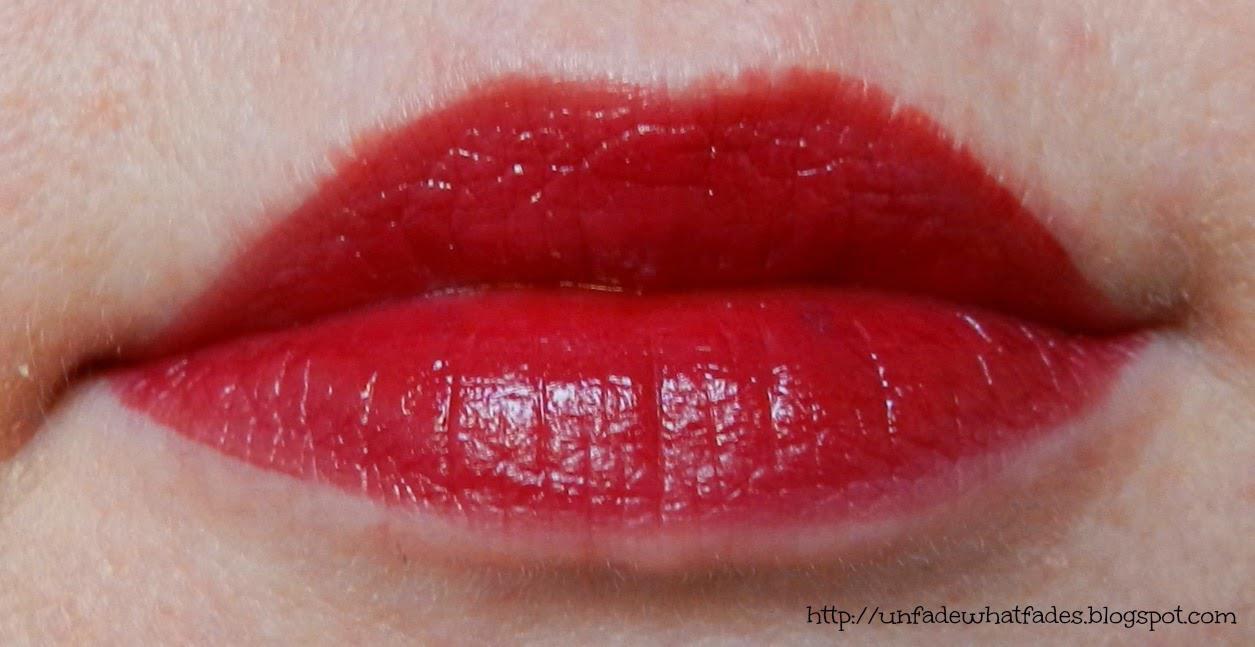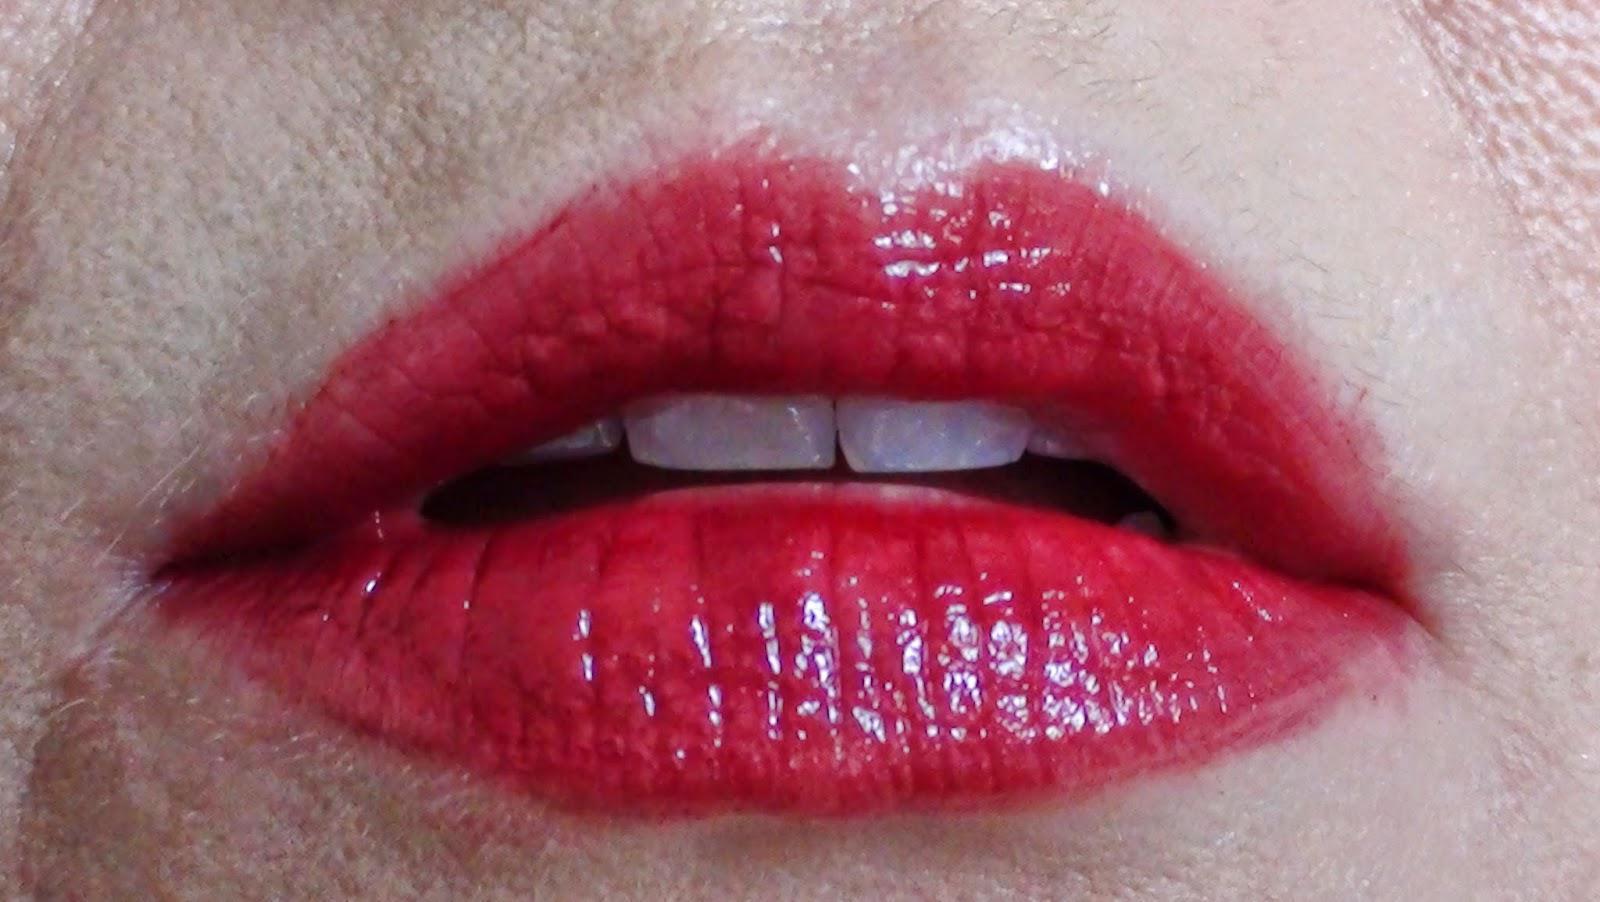The first image is the image on the left, the second image is the image on the right. Considering the images on both sides, is "The lipstick is shown on a person's lips in at least one of the images." valid? Answer yes or no. Yes. The first image is the image on the left, the second image is the image on the right. Analyze the images presented: Is the assertion "There are three tubes of lipstick." valid? Answer yes or no. No. 